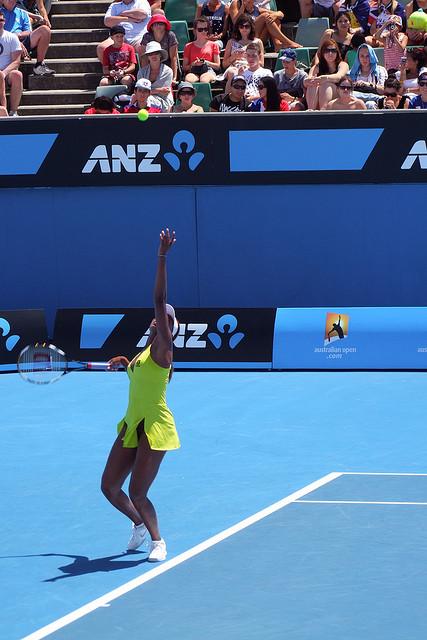What color is the court?
Write a very short answer. Blue. Is this person serving?
Give a very brief answer. Yes. What color is her dress?
Write a very short answer. Yellow. 